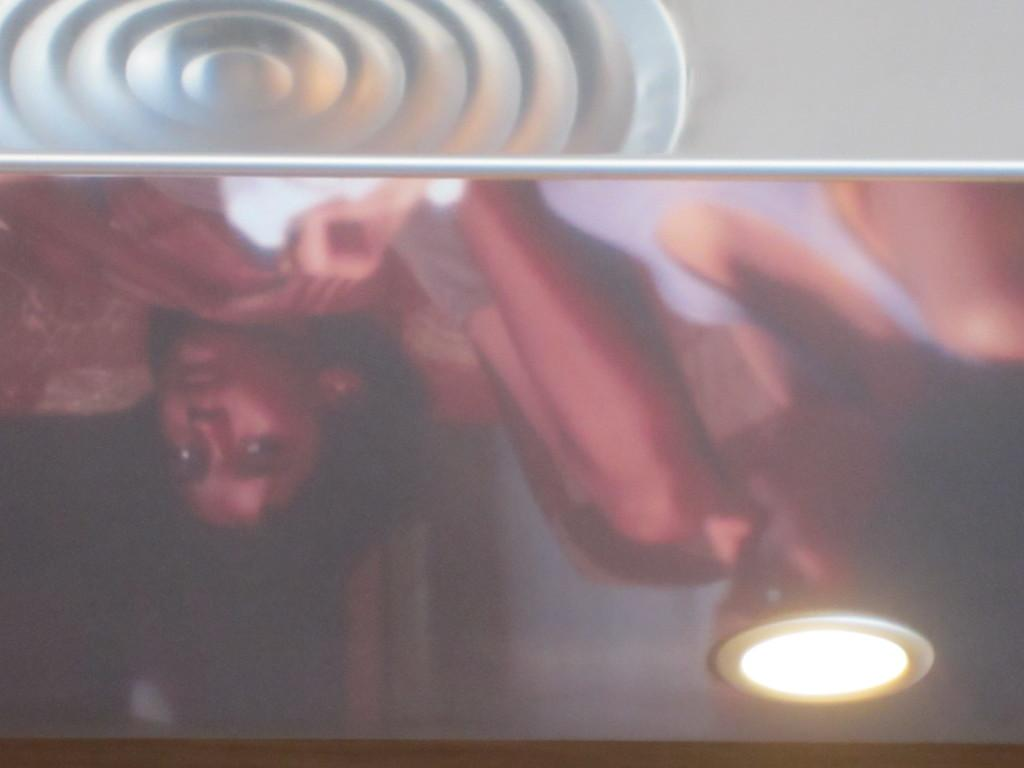What can be seen in the image that resembles people? There are reflections of persons in the image. Where is the light source located in the image? There is a light in the bottom right of the image. What is at the top of the image? There is a design at the top of the image. How does the water flow in the image? There is no water present in the image. What is being pulled in the image? There is no object being pulled in the image. 